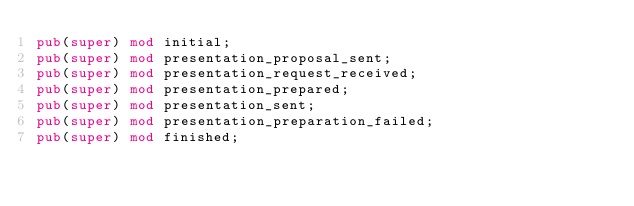<code> <loc_0><loc_0><loc_500><loc_500><_Rust_>pub(super) mod initial;
pub(super) mod presentation_proposal_sent;
pub(super) mod presentation_request_received;
pub(super) mod presentation_prepared;
pub(super) mod presentation_sent;
pub(super) mod presentation_preparation_failed;
pub(super) mod finished;
</code> 